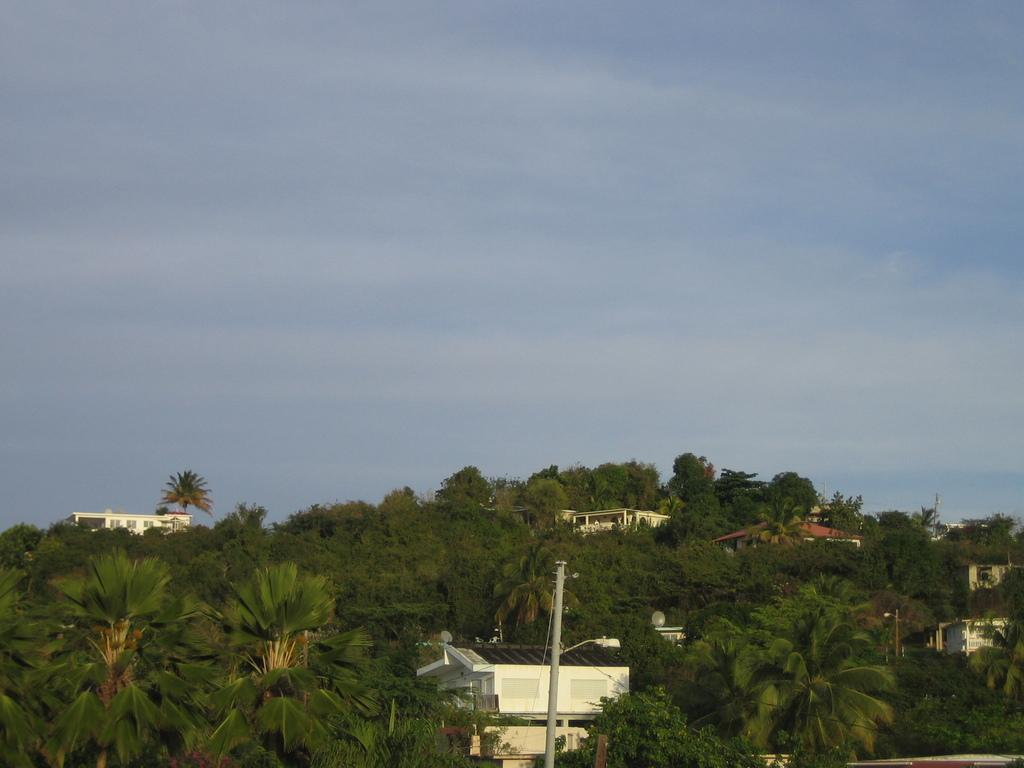What is the condition of the sky in the image? The sky is clear in the image. What type of structures can be seen in the image? There are houses in the image. What type of lighting is present in the image? There is a street light in the image. What type of wax is being used by the maid in the image? There is no maid or wax present in the image. What color is the button on the house in the image? There is no button present on the houses in the image. 